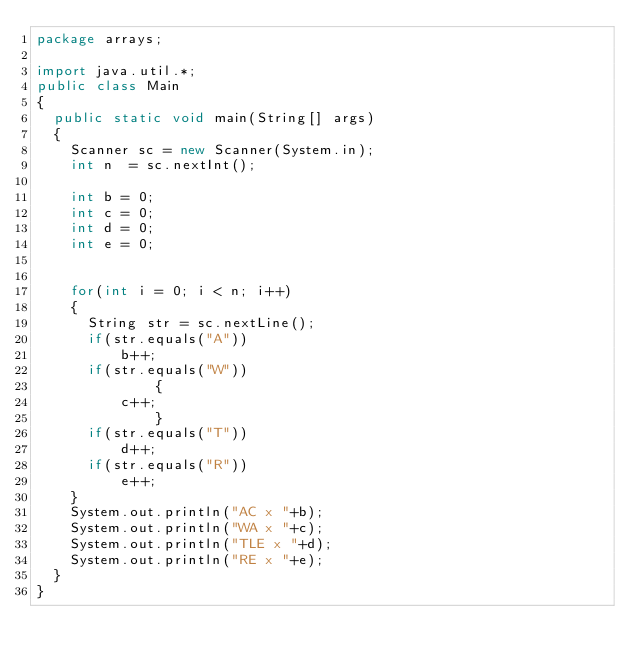Convert code to text. <code><loc_0><loc_0><loc_500><loc_500><_Java_>package arrays;

import java.util.*;
public class Main
{
  public static void main(String[] args)
  {
    Scanner sc = new Scanner(System.in); 
    int n  = sc.nextInt();
    
    int b = 0;
    int c = 0;
    int d = 0;
    int e = 0;

    
    for(int i = 0; i < n; i++)
    {
      String str = sc.nextLine();
      if(str.equals("A"))
          b++;
      if(str.equals("W"))
    		  {
          c++;
    		  }
      if(str.equals("T"))
          d++;
      if(str.equals("R"))
          e++;
    }
    System.out.println("AC x "+b);
    System.out.println("WA x "+c);
    System.out.println("TLE x "+d);
    System.out.println("RE x "+e);
  }
}                          
</code> 